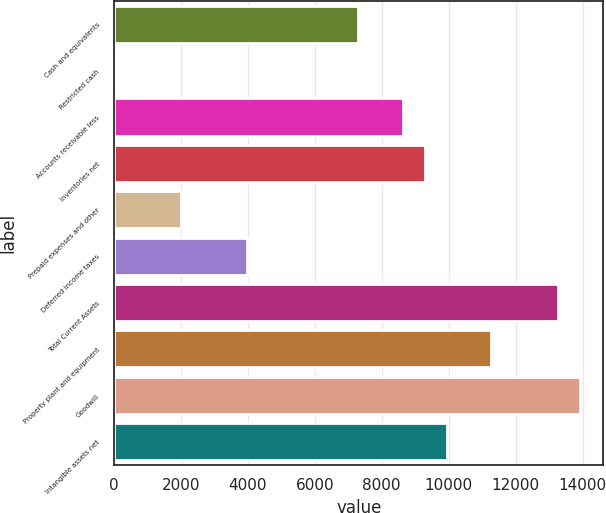<chart> <loc_0><loc_0><loc_500><loc_500><bar_chart><fcel>Cash and equivalents<fcel>Restricted cash<fcel>Accounts receivable less<fcel>Inventories net<fcel>Prepaid expenses and other<fcel>Deferred income taxes<fcel>Total Current Assets<fcel>Property plant and equipment<fcel>Goodwill<fcel>Intangible assets net<nl><fcel>7296.82<fcel>2.5<fcel>8623.06<fcel>9286.18<fcel>1991.86<fcel>3981.22<fcel>13264.9<fcel>11275.5<fcel>13928<fcel>9949.3<nl></chart> 